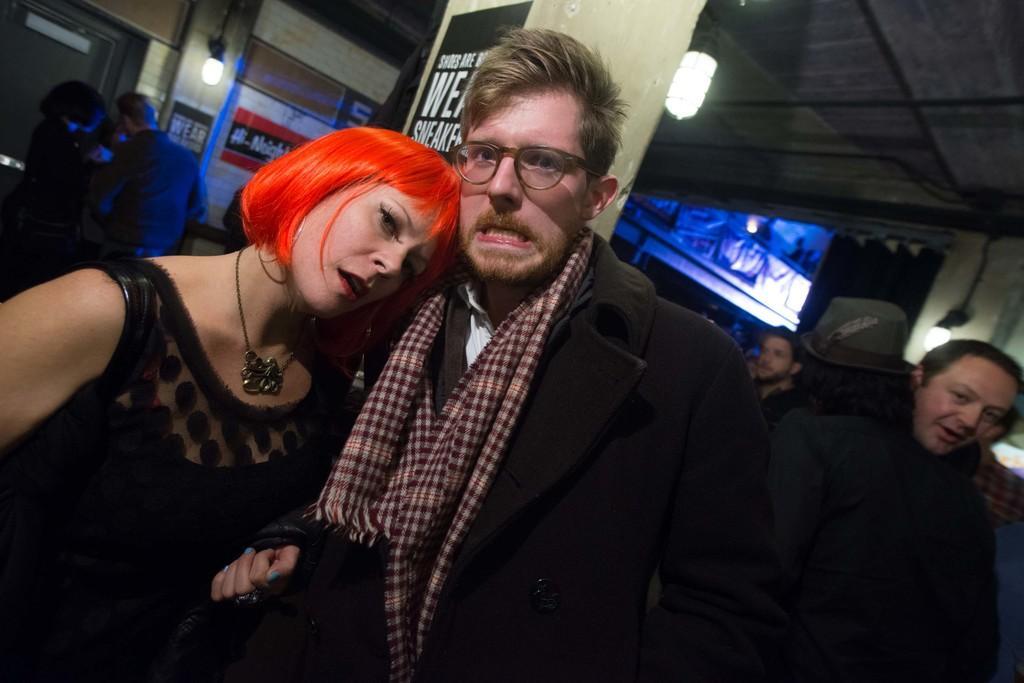Describe this image in one or two sentences. In this picture we can see a group of people standing and a man wore a spectacle and a person wore a cap and in the background we can see the lights, posters and some objects. 